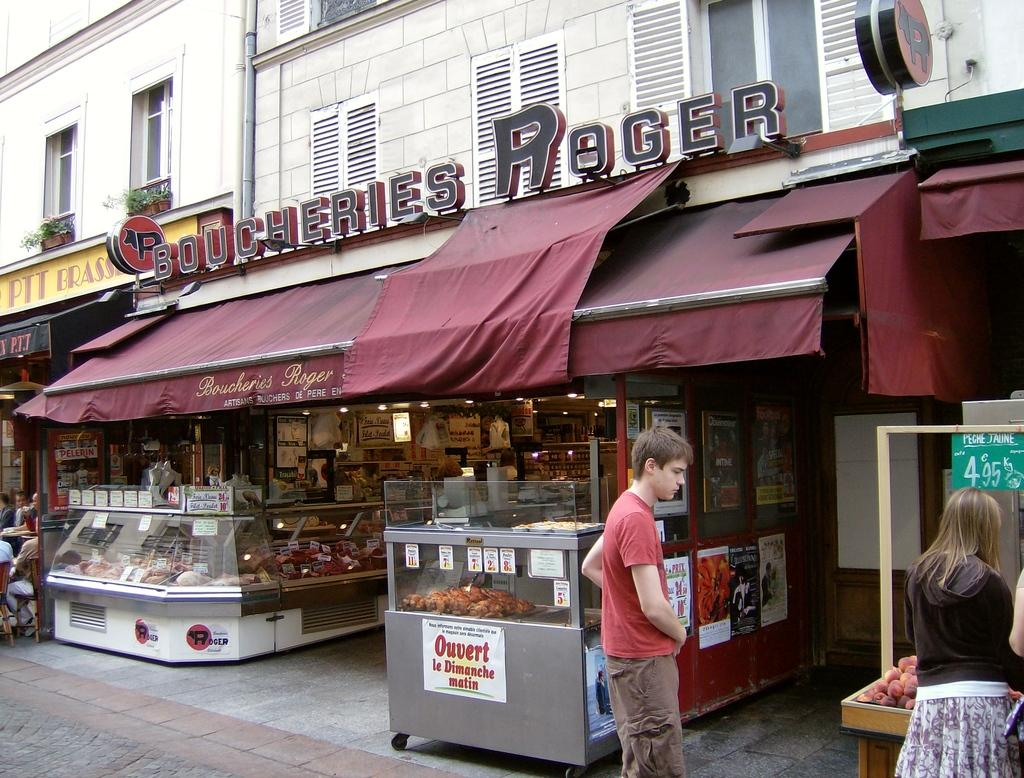<image>
Render a clear and concise summary of the photo. A street sign with a sign reading Boucheries Roger 